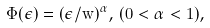Convert formula to latex. <formula><loc_0><loc_0><loc_500><loc_500>\hat { \Phi } ( \epsilon ) = ( \epsilon / \hat { w } ) ^ { \alpha } , \, ( 0 < \alpha < 1 ) ,</formula> 